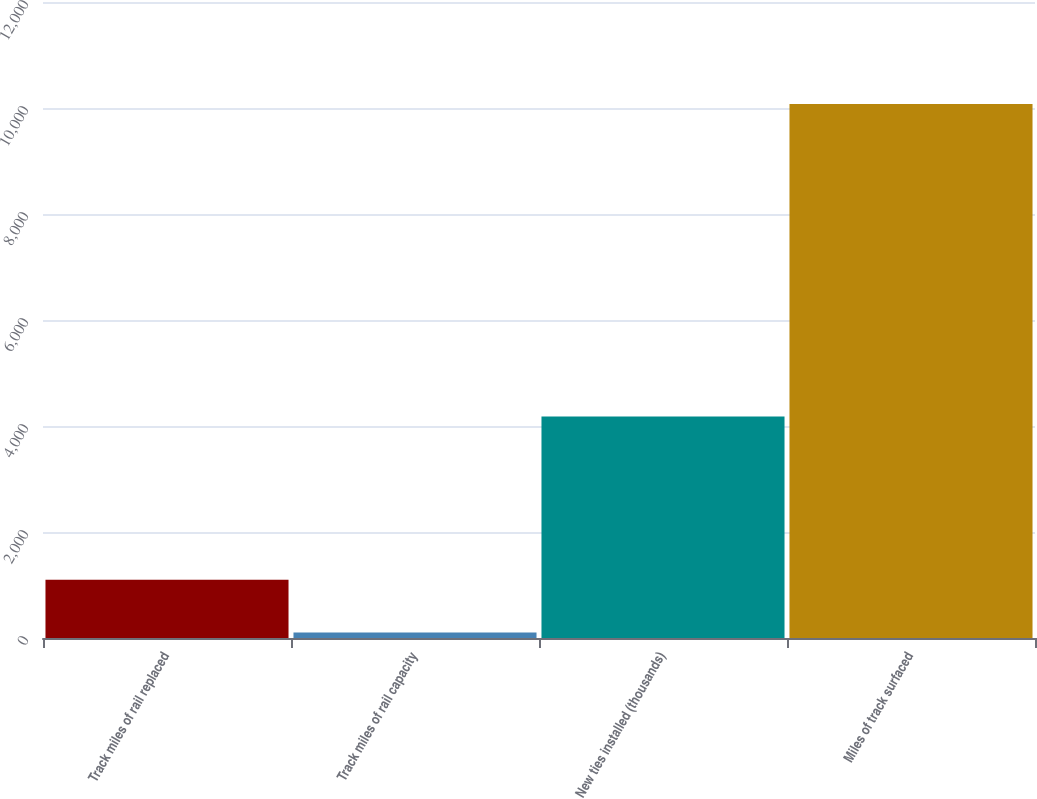Convert chart. <chart><loc_0><loc_0><loc_500><loc_500><bar_chart><fcel>Track miles of rail replaced<fcel>Track miles of rail capacity<fcel>New ties installed (thousands)<fcel>Miles of track surfaced<nl><fcel>1100.3<fcel>103<fcel>4178<fcel>10076<nl></chart> 